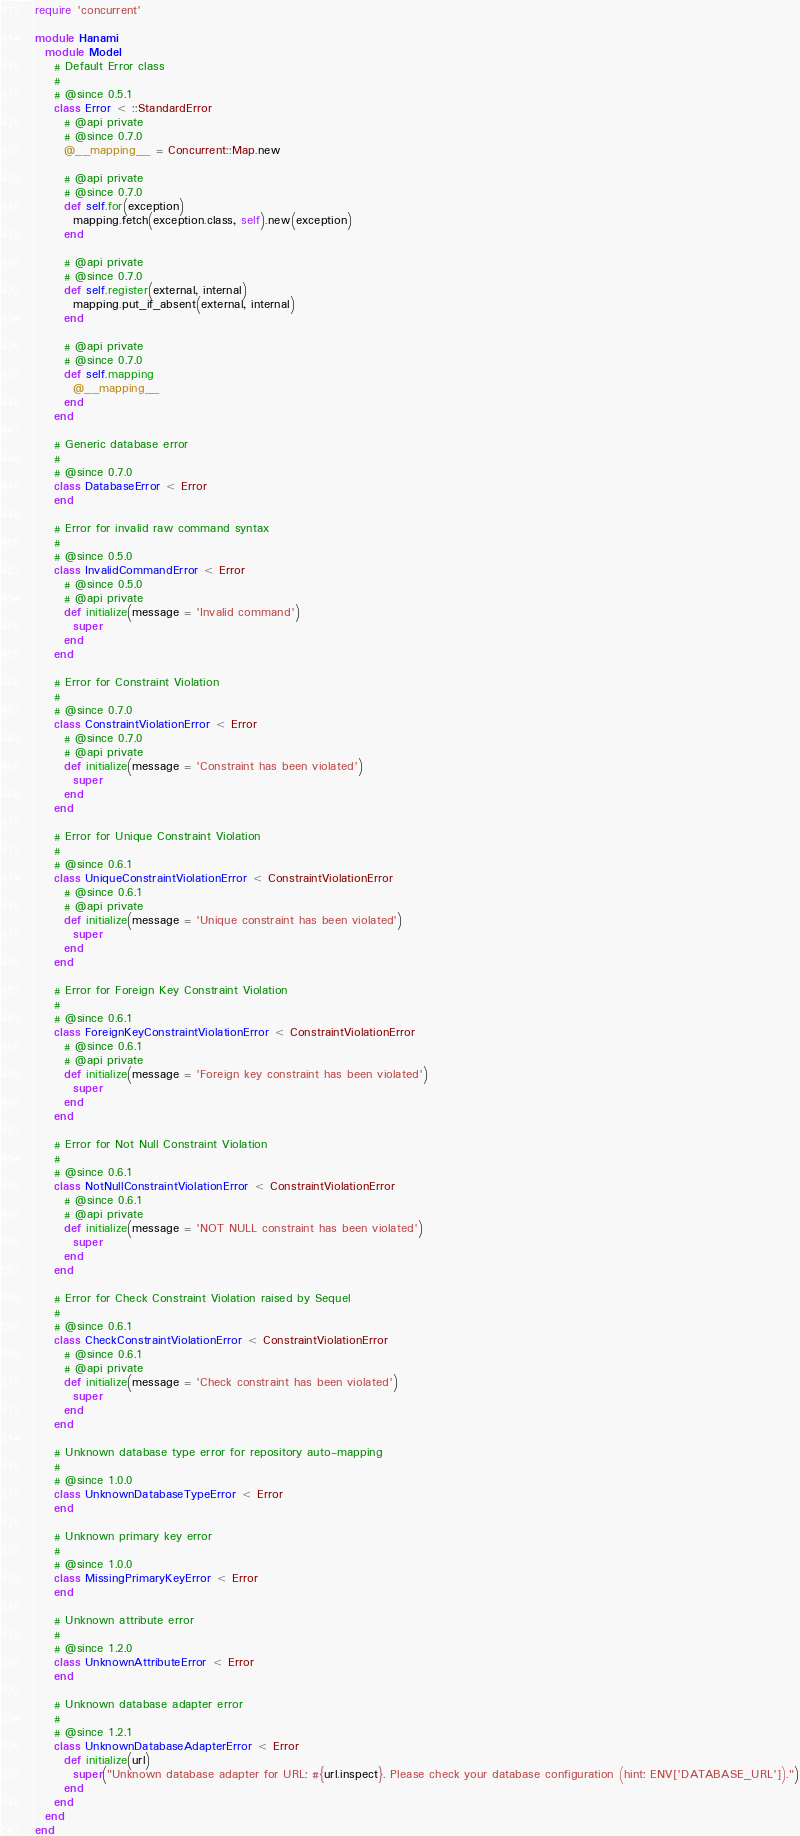Convert code to text. <code><loc_0><loc_0><loc_500><loc_500><_Ruby_>require 'concurrent'

module Hanami
  module Model
    # Default Error class
    #
    # @since 0.5.1
    class Error < ::StandardError
      # @api private
      # @since 0.7.0
      @__mapping__ = Concurrent::Map.new

      # @api private
      # @since 0.7.0
      def self.for(exception)
        mapping.fetch(exception.class, self).new(exception)
      end

      # @api private
      # @since 0.7.0
      def self.register(external, internal)
        mapping.put_if_absent(external, internal)
      end

      # @api private
      # @since 0.7.0
      def self.mapping
        @__mapping__
      end
    end

    # Generic database error
    #
    # @since 0.7.0
    class DatabaseError < Error
    end

    # Error for invalid raw command syntax
    #
    # @since 0.5.0
    class InvalidCommandError < Error
      # @since 0.5.0
      # @api private
      def initialize(message = 'Invalid command')
        super
      end
    end

    # Error for Constraint Violation
    #
    # @since 0.7.0
    class ConstraintViolationError < Error
      # @since 0.7.0
      # @api private
      def initialize(message = 'Constraint has been violated')
        super
      end
    end

    # Error for Unique Constraint Violation
    #
    # @since 0.6.1
    class UniqueConstraintViolationError < ConstraintViolationError
      # @since 0.6.1
      # @api private
      def initialize(message = 'Unique constraint has been violated')
        super
      end
    end

    # Error for Foreign Key Constraint Violation
    #
    # @since 0.6.1
    class ForeignKeyConstraintViolationError < ConstraintViolationError
      # @since 0.6.1
      # @api private
      def initialize(message = 'Foreign key constraint has been violated')
        super
      end
    end

    # Error for Not Null Constraint Violation
    #
    # @since 0.6.1
    class NotNullConstraintViolationError < ConstraintViolationError
      # @since 0.6.1
      # @api private
      def initialize(message = 'NOT NULL constraint has been violated')
        super
      end
    end

    # Error for Check Constraint Violation raised by Sequel
    #
    # @since 0.6.1
    class CheckConstraintViolationError < ConstraintViolationError
      # @since 0.6.1
      # @api private
      def initialize(message = 'Check constraint has been violated')
        super
      end
    end

    # Unknown database type error for repository auto-mapping
    #
    # @since 1.0.0
    class UnknownDatabaseTypeError < Error
    end

    # Unknown primary key error
    #
    # @since 1.0.0
    class MissingPrimaryKeyError < Error
    end

    # Unknown attribute error
    #
    # @since 1.2.0
    class UnknownAttributeError < Error
    end

    # Unknown database adapter error
    #
    # @since 1.2.1
    class UnknownDatabaseAdapterError < Error
      def initialize(url)
        super("Unknown database adapter for URL: #{url.inspect}. Please check your database configuration (hint: ENV['DATABASE_URL']).")
      end
    end
  end
end
</code> 